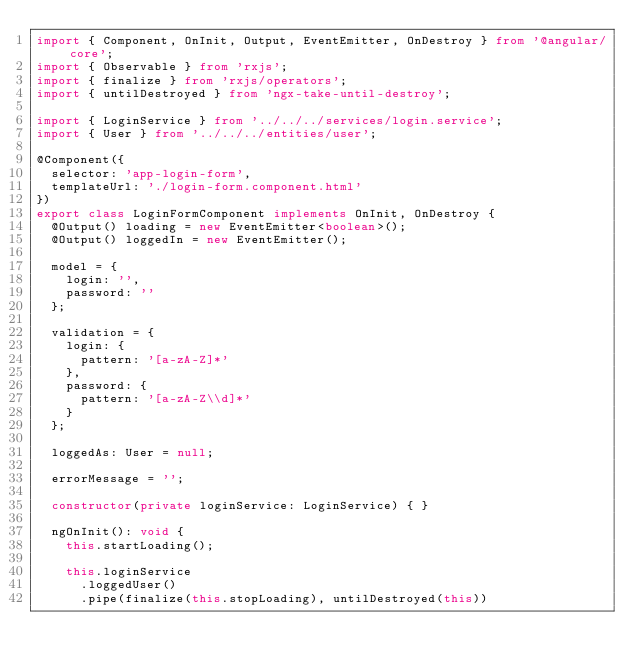Convert code to text. <code><loc_0><loc_0><loc_500><loc_500><_TypeScript_>import { Component, OnInit, Output, EventEmitter, OnDestroy } from '@angular/core';
import { Observable } from 'rxjs';
import { finalize } from 'rxjs/operators';
import { untilDestroyed } from 'ngx-take-until-destroy';

import { LoginService } from '../../../services/login.service';
import { User } from '../../../entities/user';

@Component({
  selector: 'app-login-form',
  templateUrl: './login-form.component.html'
})
export class LoginFormComponent implements OnInit, OnDestroy {
  @Output() loading = new EventEmitter<boolean>();
  @Output() loggedIn = new EventEmitter();

  model = {
    login: '',
    password: ''
  };

  validation = {
    login: {
      pattern: '[a-zA-Z]*'
    },
    password: {
      pattern: '[a-zA-Z\\d]*'
    }
  };

  loggedAs: User = null;

  errorMessage = '';

  constructor(private loginService: LoginService) { }

  ngOnInit(): void {
    this.startLoading();

    this.loginService
      .loggedUser()
      .pipe(finalize(this.stopLoading), untilDestroyed(this))</code> 